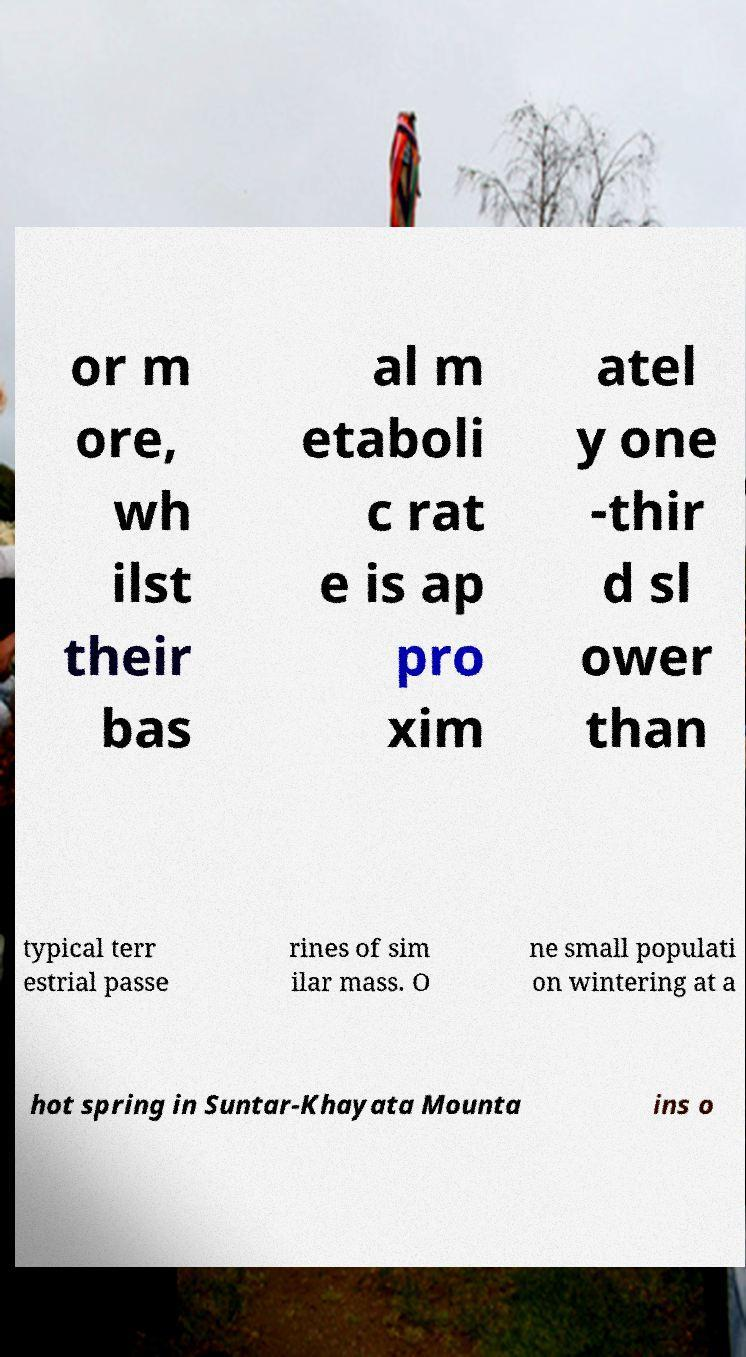There's text embedded in this image that I need extracted. Can you transcribe it verbatim? or m ore, wh ilst their bas al m etaboli c rat e is ap pro xim atel y one -thir d sl ower than typical terr estrial passe rines of sim ilar mass. O ne small populati on wintering at a hot spring in Suntar-Khayata Mounta ins o 